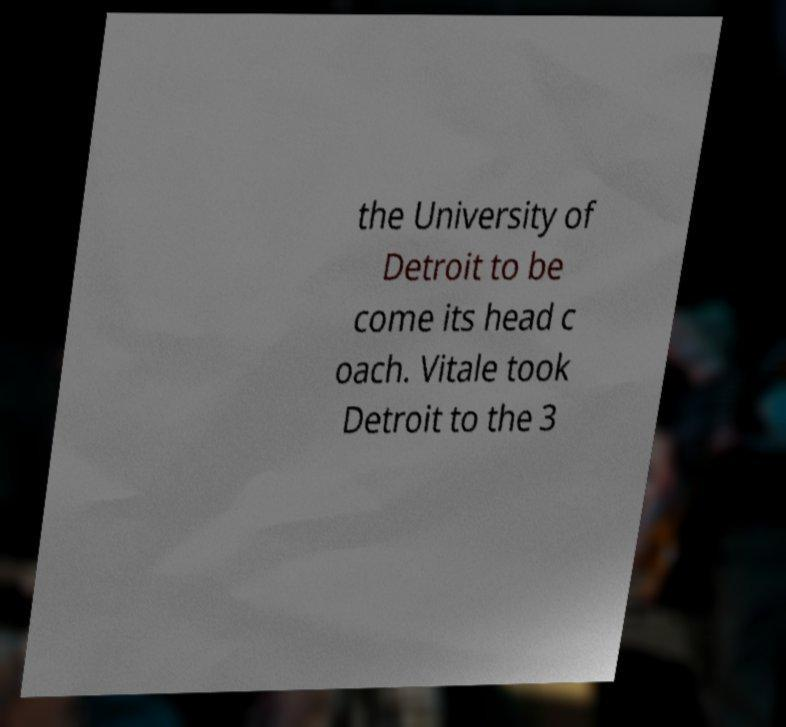I need the written content from this picture converted into text. Can you do that? the University of Detroit to be come its head c oach. Vitale took Detroit to the 3 